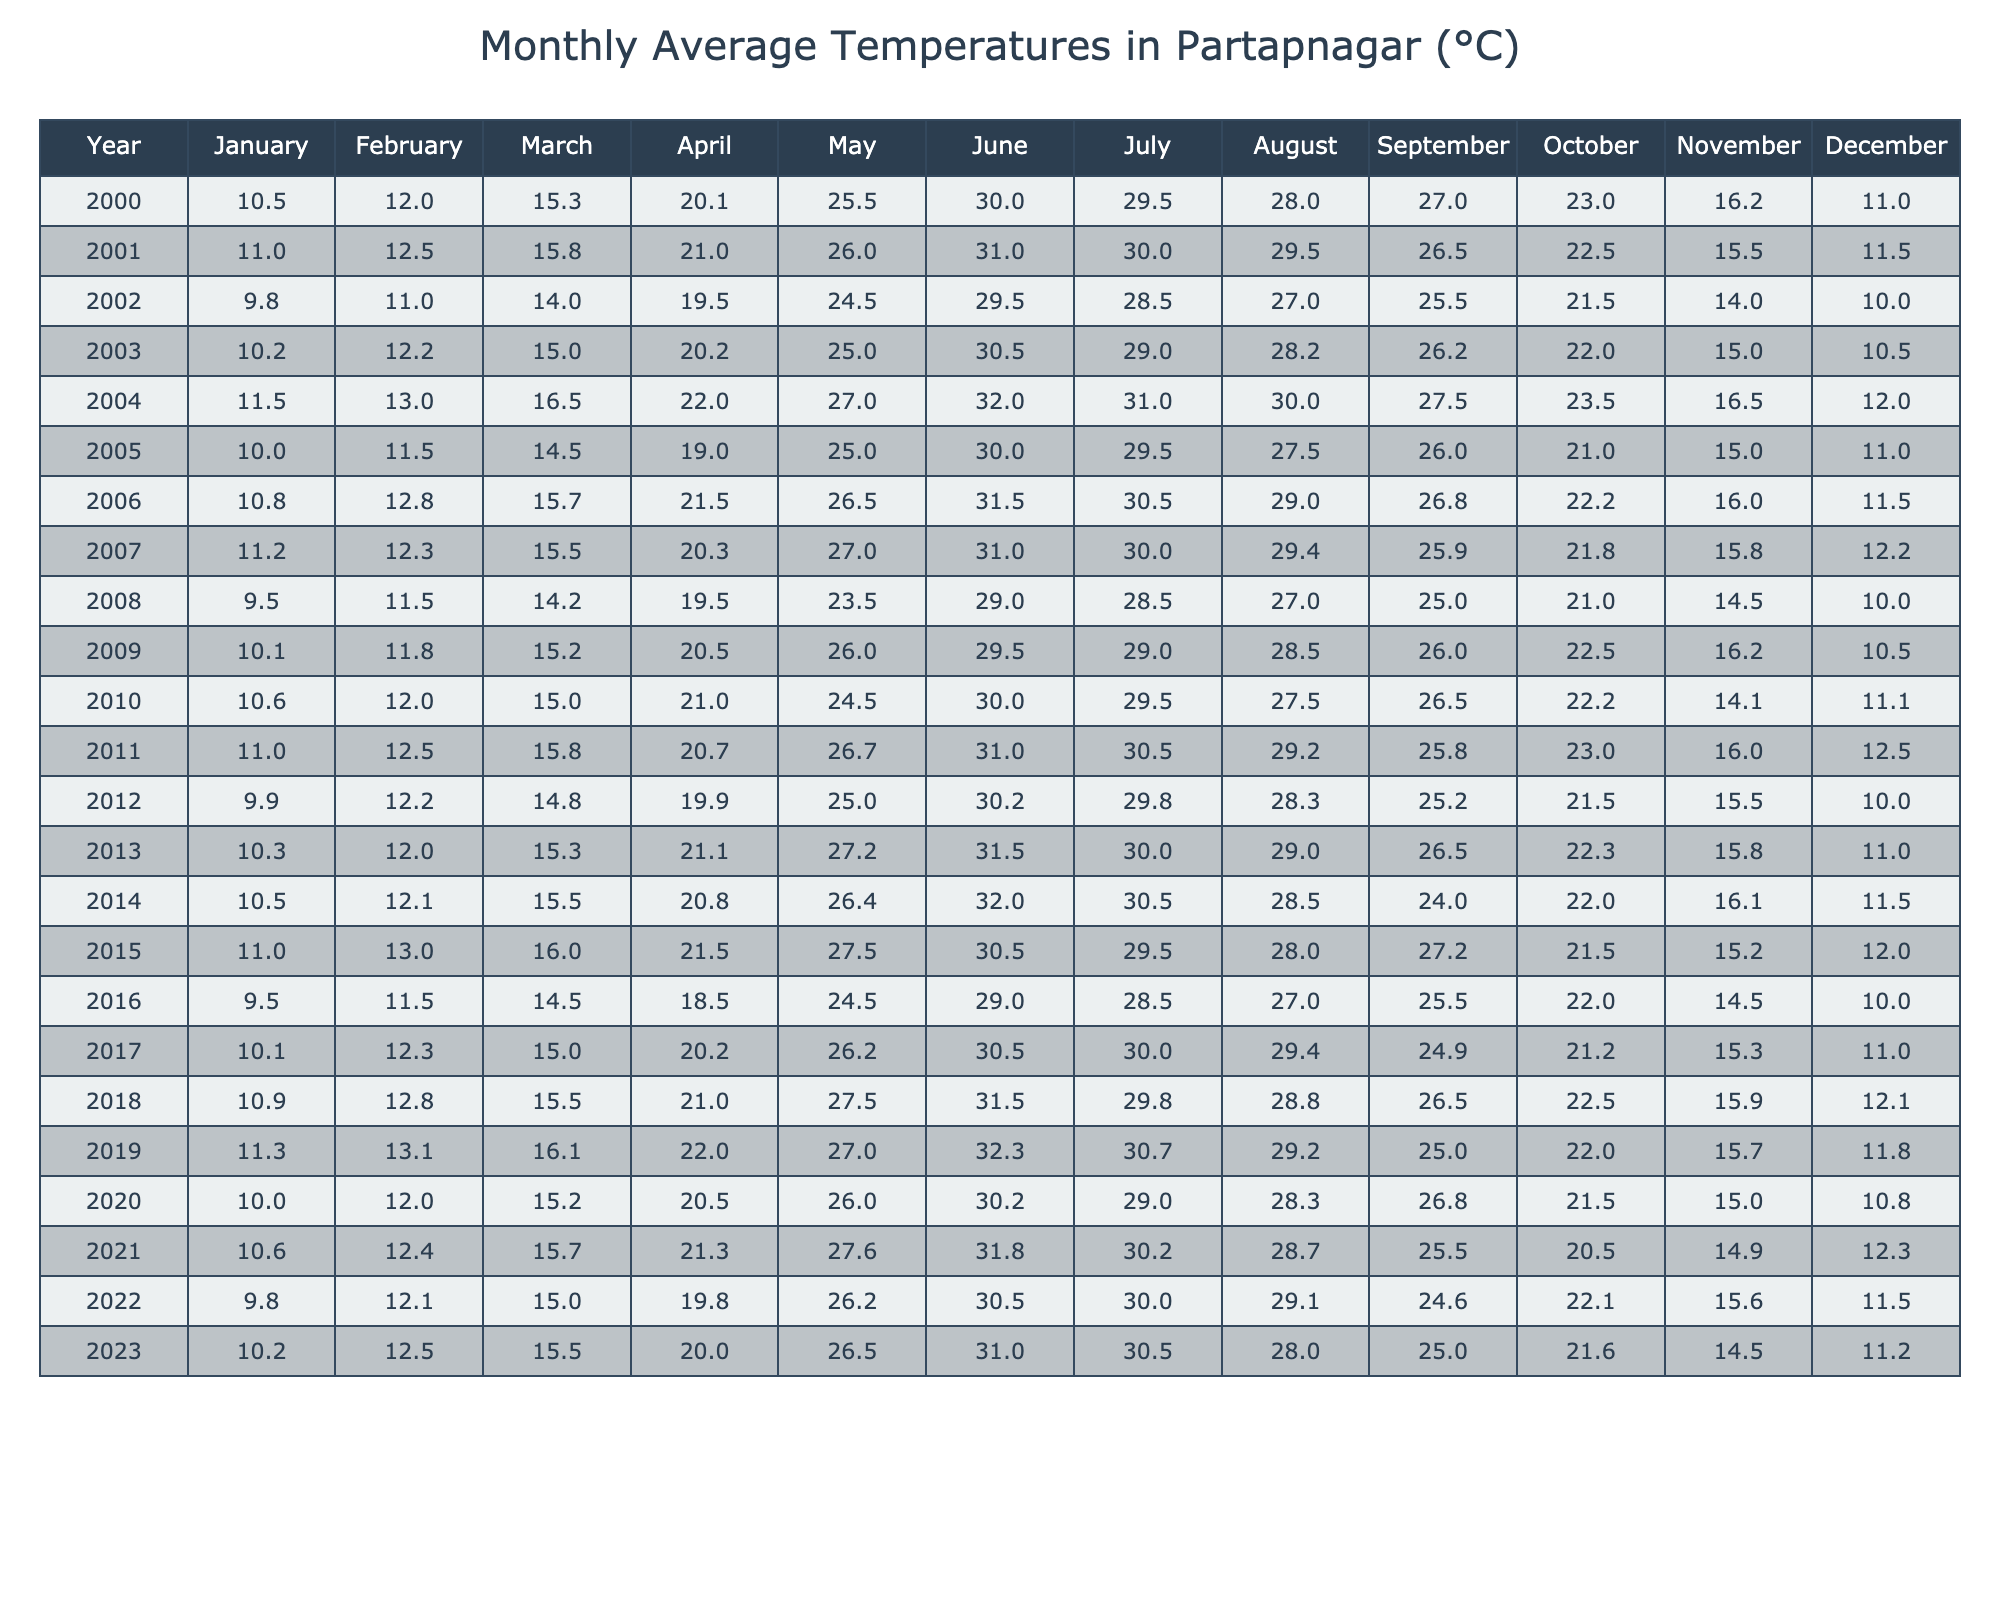What's the average temperature in July for the year 2010? The value for July in 2010 is 29.5°C, so the average temperature for July that year is simply that number.
Answer: 29.5°C Which month had the highest average temperature in 2022? To find the highest average temperature in 2022, I compare all monthly temperatures listed for that year. The highest value is for June at 30.5°C.
Answer: June In which year did the average temperature in February reach its highest value? I look at the February temperatures for each year, and upon comparing the values, I notice 2019 has the highest average temperature in February at 13.1°C.
Answer: 2019 What was the temperature difference between the highest and lowest average temperature in January from 2000 to 2023? The highest January temperature is 11.5°C in 2004, while the lowest is 9.5°C in 2008. The difference is calculated as 11.5°C - 9.5°C = 2.0°C.
Answer: 2.0°C Did the average temperature in December ever drop below 11.0°C between 2000 and 2023? By checking the December values, I see the lowest temperature recorded is 10.0°C in both 2002 and 2008, which confirms that it did drop below 11.0°C.
Answer: Yes What is the average temperature in March over the years from 2000 to 2023? To calculate this, I sum all the March temperatures (15.3 + 15.8 + 14.0 + 15.0 + 16.5 + 14.5 + 15.5 + 14.2 + 15.2 + 15.0 + 15.8 + 14.8 + 15.3 + 15.5 + 16.0 + 14.5 + 15.0 + 15.5) and divide by 24 to get the average, approximately 15.2°C.
Answer: 15.2°C How many years had an average temperature in July of 30.0°C or higher? By examining the July temperatures, I identify the years where the temperature is 30.0°C or higher (2001, 2004, 2006, 2007, 2011, 2012, 2015, 2018, 2019, 2020, 2021, 2023), totaling 12 years.
Answer: 12 years Which month saw the lowest average temperature in 2016? Upon reviewing the 2016 data, I find the lowest average temperature is in December, which is 10.0°C.
Answer: December What was the trend for the average temperatures from 2000 to 2023 in Partapnagar? An overall review of the data shows that the average temperatures for most months showed a gradual increase, especially from 2000 to 2023, indicating a warming trend.
Answer: Increasing trend 